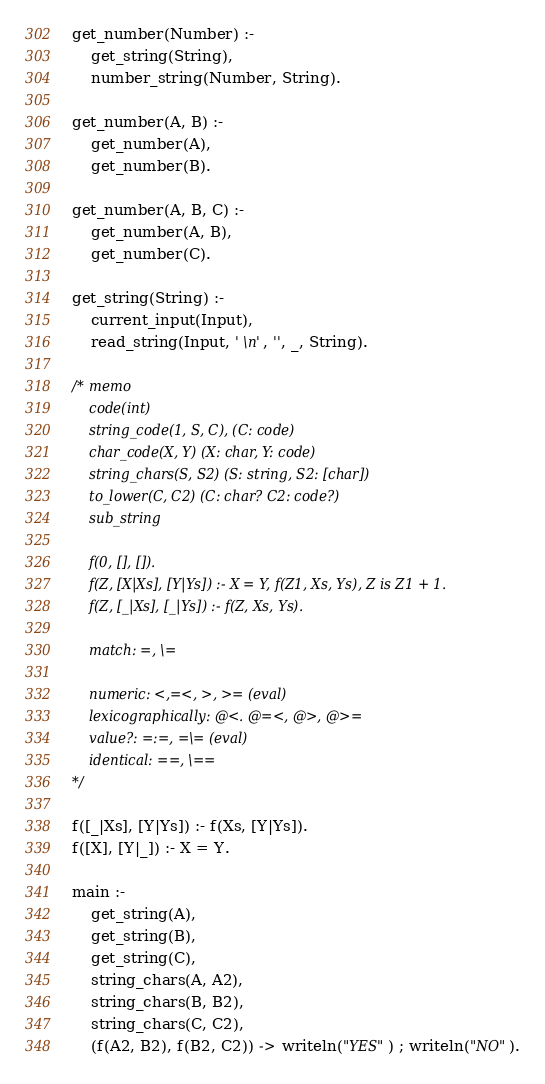Convert code to text. <code><loc_0><loc_0><loc_500><loc_500><_Prolog_>get_number(Number) :-
    get_string(String),
    number_string(Number, String).

get_number(A, B) :-
    get_number(A),
    get_number(B).

get_number(A, B, C) :-
    get_number(A, B),
    get_number(C).

get_string(String) :-
    current_input(Input),
    read_string(Input, ' \n', '', _, String).

/* memo
    code(int)
    string_code(1, S, C), (C: code)
    char_code(X, Y) (X: char, Y: code)
    string_chars(S, S2) (S: string, S2: [char])
    to_lower(C, C2) (C: char? C2: code?)
    sub_string

    f(0, [], []).
    f(Z, [X|Xs], [Y|Ys]) :- X = Y, f(Z1, Xs, Ys), Z is Z1 + 1.
    f(Z, [_|Xs], [_|Ys]) :- f(Z, Xs, Ys).

    match: =, \=

    numeric: <,=<, >, >= (eval)
    lexicographically: @<. @=<, @>, @>=
    value?: =:=, =\= (eval)
    identical: ==, \==
*/

f([_|Xs], [Y|Ys]) :- f(Xs, [Y|Ys]).
f([X], [Y|_]) :- X = Y.

main :-
    get_string(A),
    get_string(B),
    get_string(C),
    string_chars(A, A2),
    string_chars(B, B2),
    string_chars(C, C2),
    (f(A2, B2), f(B2, C2)) -> writeln("YES") ; writeln("NO").
</code> 